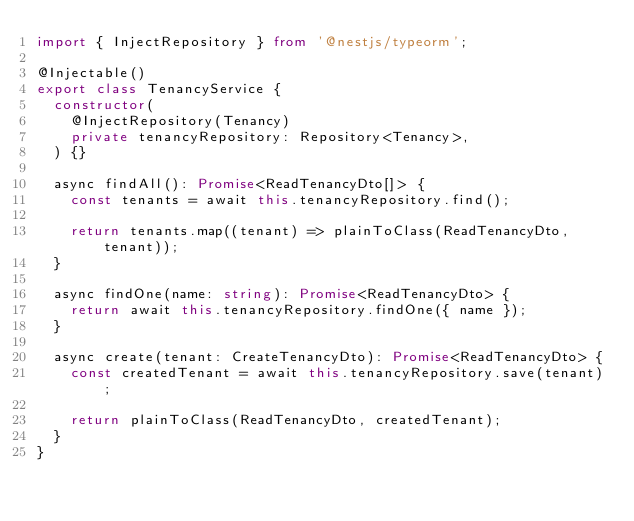Convert code to text. <code><loc_0><loc_0><loc_500><loc_500><_TypeScript_>import { InjectRepository } from '@nestjs/typeorm';

@Injectable()
export class TenancyService {
  constructor(
    @InjectRepository(Tenancy)
    private tenancyRepository: Repository<Tenancy>,
  ) {}

  async findAll(): Promise<ReadTenancyDto[]> {
    const tenants = await this.tenancyRepository.find();

    return tenants.map((tenant) => plainToClass(ReadTenancyDto, tenant));
  }

  async findOne(name: string): Promise<ReadTenancyDto> {
    return await this.tenancyRepository.findOne({ name });
  }

  async create(tenant: CreateTenancyDto): Promise<ReadTenancyDto> {
    const createdTenant = await this.tenancyRepository.save(tenant);

    return plainToClass(ReadTenancyDto, createdTenant);
  }
}
</code> 